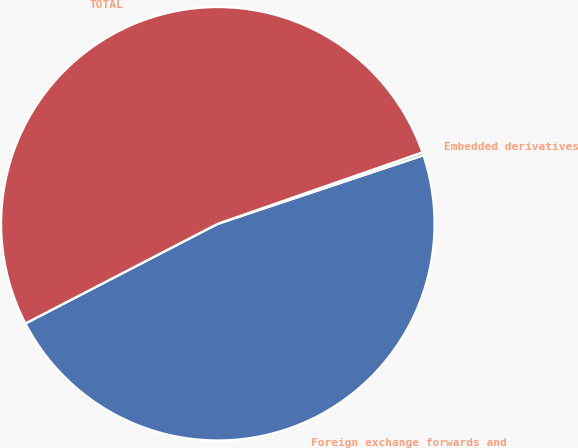<chart> <loc_0><loc_0><loc_500><loc_500><pie_chart><fcel>Foreign exchange forwards and<fcel>Embedded derivatives<fcel>TOTAL<nl><fcel>47.51%<fcel>0.22%<fcel>52.27%<nl></chart> 